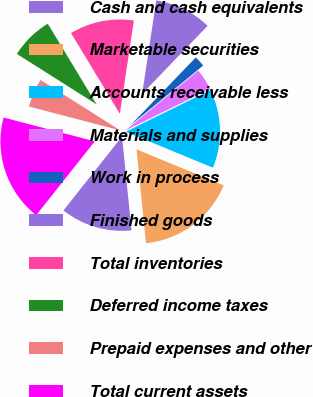<chart> <loc_0><loc_0><loc_500><loc_500><pie_chart><fcel>Cash and cash equivalents<fcel>Marketable securities<fcel>Accounts receivable less<fcel>Materials and supplies<fcel>Work in process<fcel>Finished goods<fcel>Total inventories<fcel>Deferred income taxes<fcel>Prepaid expenses and other<fcel>Total current assets<nl><fcel>12.27%<fcel>17.17%<fcel>13.49%<fcel>3.69%<fcel>1.85%<fcel>9.82%<fcel>11.04%<fcel>7.36%<fcel>4.91%<fcel>18.4%<nl></chart> 